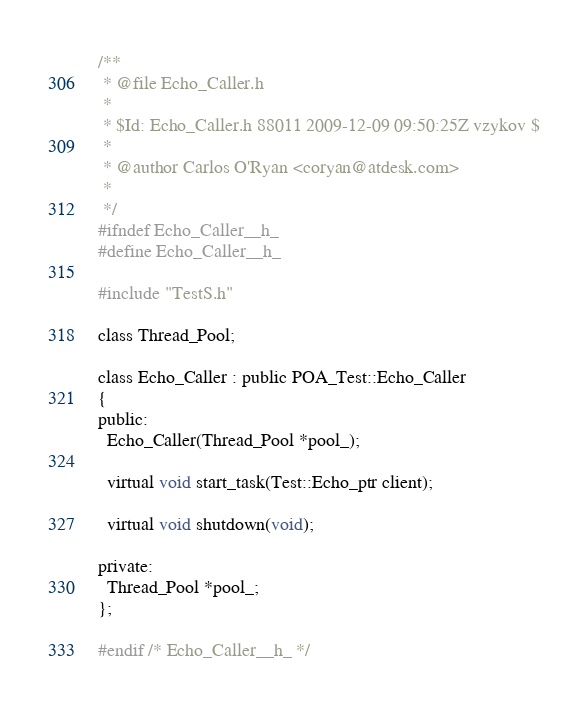<code> <loc_0><loc_0><loc_500><loc_500><_C_>/**
 * @file Echo_Caller.h
 *
 * $Id: Echo_Caller.h 88011 2009-12-09 09:50:25Z vzykov $
 *
 * @author Carlos O'Ryan <coryan@atdesk.com>
 *
 */
#ifndef Echo_Caller__h_
#define Echo_Caller__h_

#include "TestS.h"

class Thread_Pool;

class Echo_Caller : public POA_Test::Echo_Caller
{
public:
  Echo_Caller(Thread_Pool *pool_);

  virtual void start_task(Test::Echo_ptr client);

  virtual void shutdown(void);

private:
  Thread_Pool *pool_;
};

#endif /* Echo_Caller__h_ */
</code> 